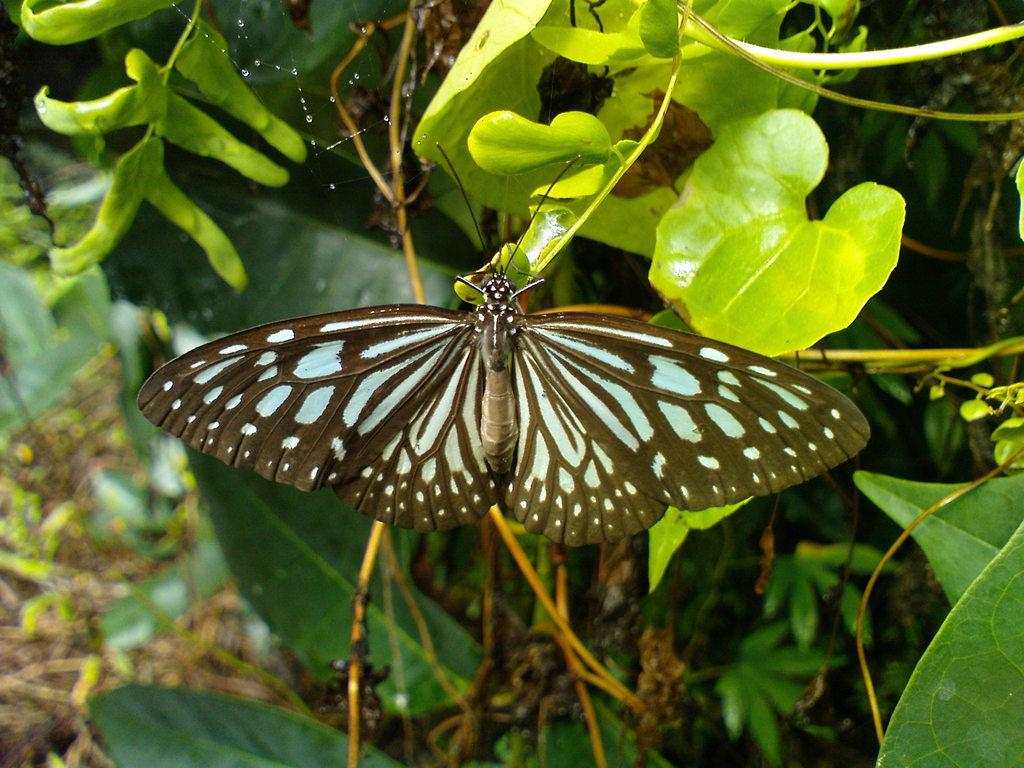What is the main subject of the picture? There is a butterfly in the picture. What can be seen in the background of the picture? There are trees in the background of the picture. What is located on the left side of the picture? There are twigs on the left side of the picture. Can you describe the quality of the bottom of the picture? The bottom of the picture is blurred. How does the butterfly participate in the competition in the image? There is no competition present in the image, and therefore the butterfly does not participate in any competition. What type of debt is the butterfly trying to pay off in the image? There is no debt present in the image, and therefore the butterfly does not attempt to pay off any debt. 